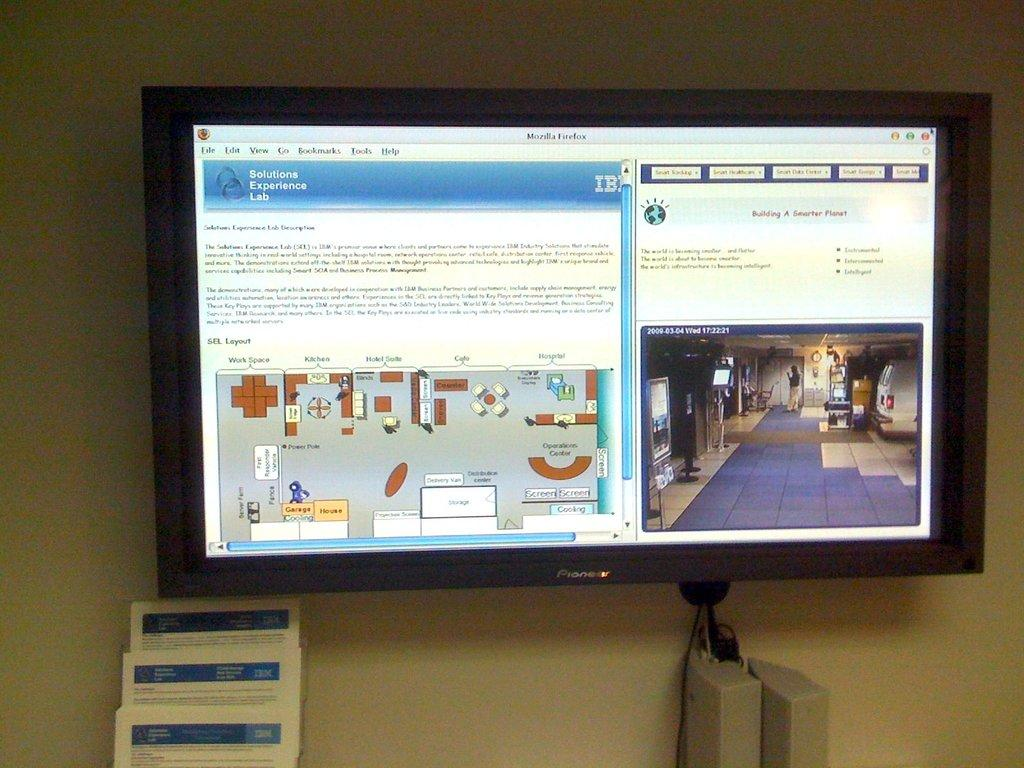Provide a one-sentence caption for the provided image. A computer monitor shows a diagram of a room layout and an image of a room. 